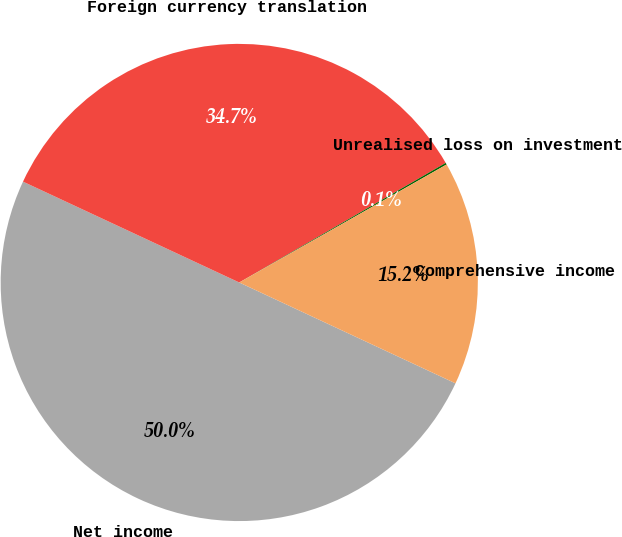<chart> <loc_0><loc_0><loc_500><loc_500><pie_chart><fcel>Net income<fcel>Foreign currency translation<fcel>Unrealised loss on investment<fcel>Comprehensive income<nl><fcel>50.0%<fcel>34.7%<fcel>0.12%<fcel>15.18%<nl></chart> 